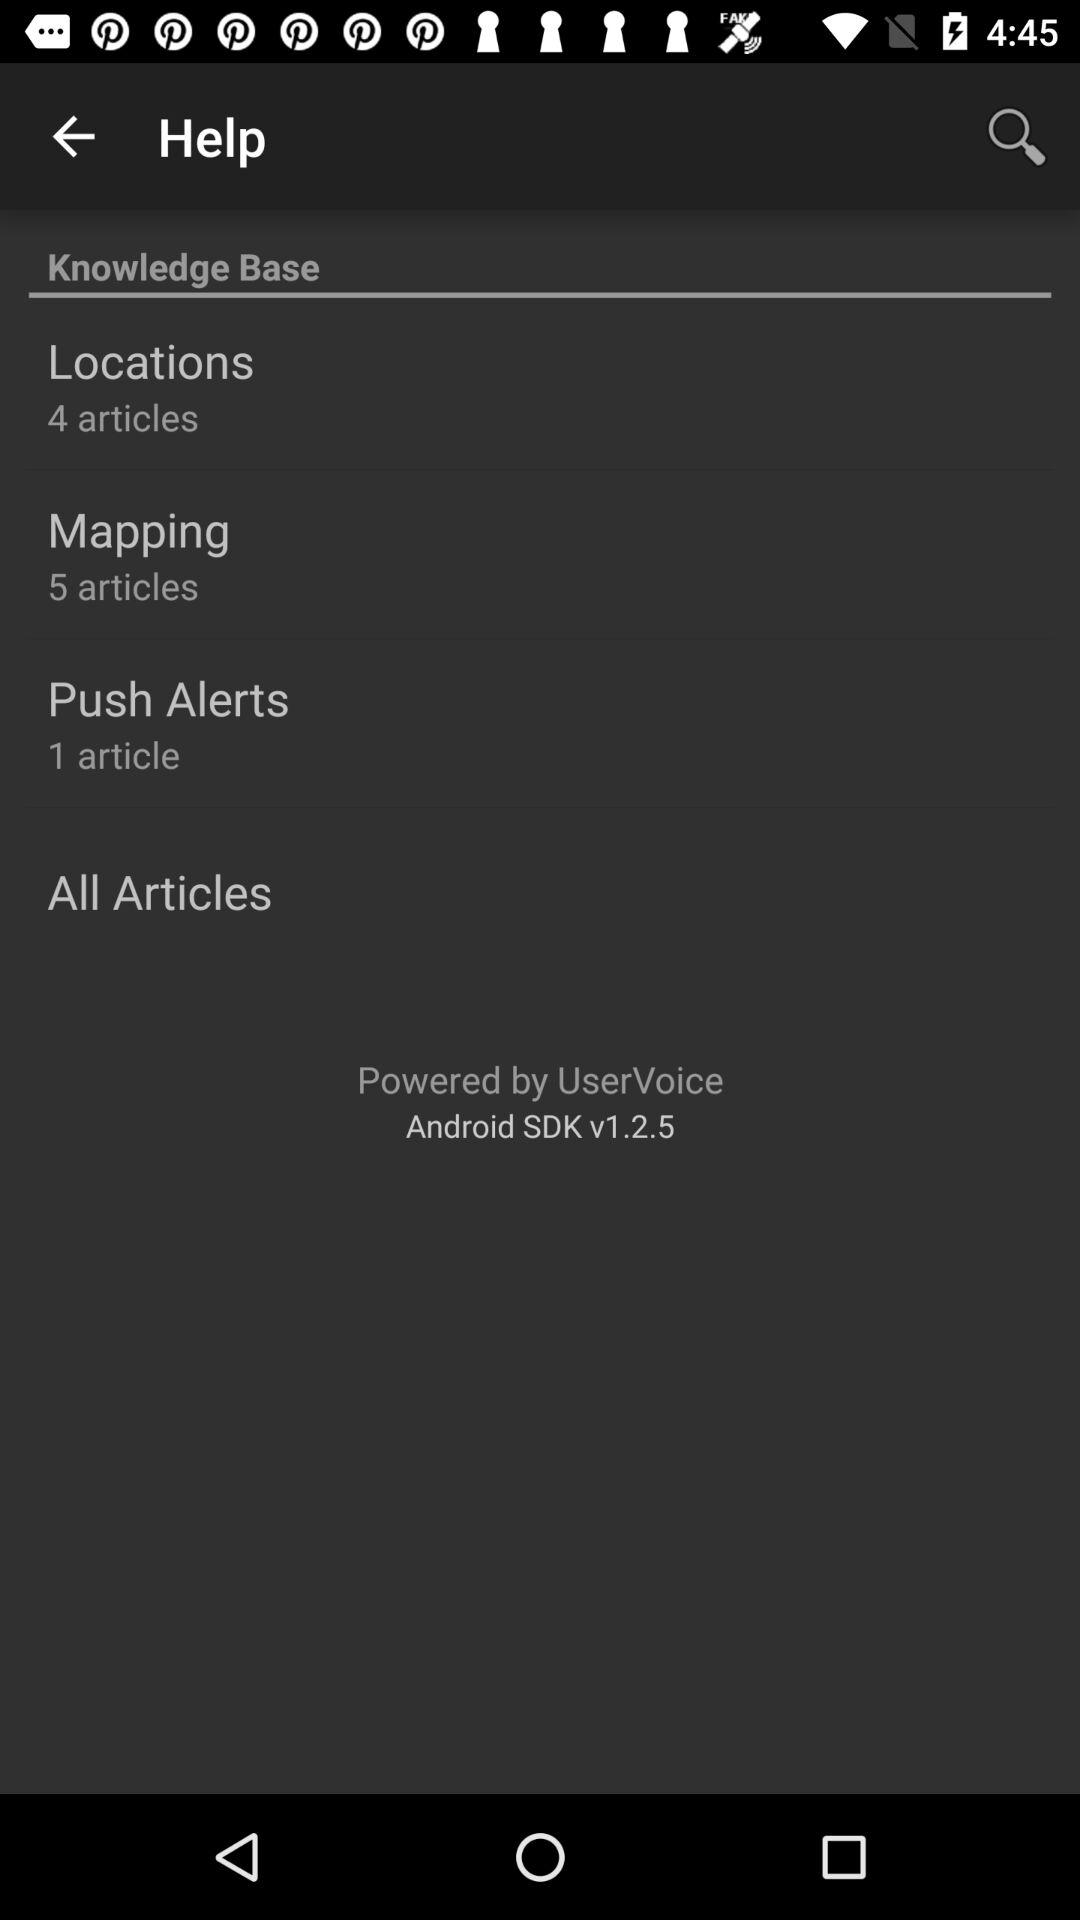How many articles are there in mapping? There are 5 articles in mapping. 